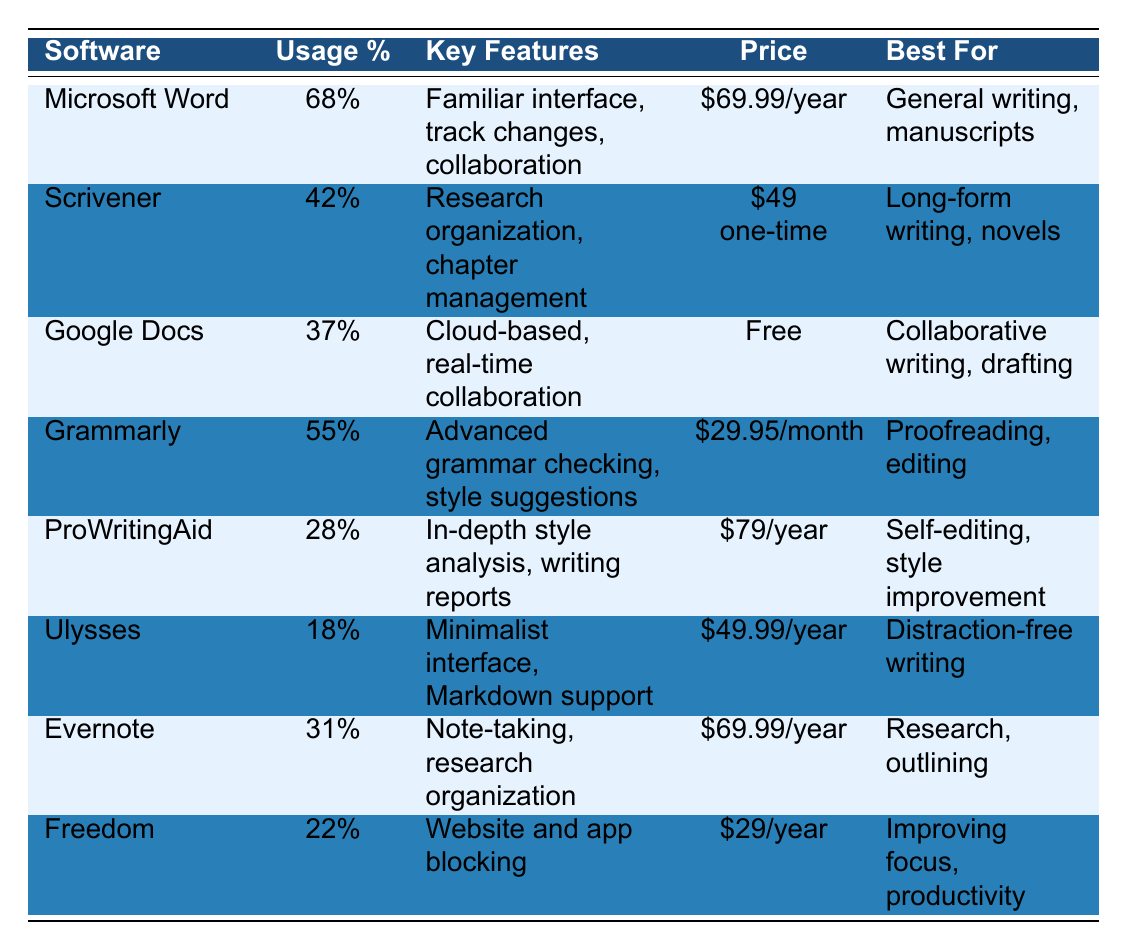What is the most popular writing software among published authors? The table shows the usage percentage of various writing software, with Microsoft Word having the highest at 68%.
Answer: Microsoft Word Which software has the lowest usage percentage? By comparing the usage percentages, Ulysses has the lowest at 18%.
Answer: Ulysses What is the price of Grammarly? The table lists Grammarly's price as $29.95 per month.
Answer: $29.95/month Is Google Docs a paid software? The table indicates that Google Docs is free, so this is a no.
Answer: No How many writing tools have a usage percentage of 30% or less? The following tools have usage percentages of 30% or less: ProWritingAid (28%), Freedom (22%), and Ulysses (18%). That's three tools.
Answer: 3 Calculate the average usage percentage of all listed writing tools. The total usage percentages sum up to 68 + 42 + 37 + 55 + 28 + 18 + 31 + 22 =  303. There are 8 tools, so the average is 303/8 = 37.875%.
Answer: 37.875% Which writing tool is best for long-form writing and how much does it cost? Scrivener is noted as best for long-form writing, and its price is $49 as a one-time fee.
Answer: Scrivener, $49 How does the usage percentage of Grammarly compare to that of ProWritingAid? Grammarly has a 55% usage whereas ProWritingAid has a 28% usage, showing that Grammarly is more widely used.
Answer: Grammarly is more widely used What are the key features of Microsoft Word? The table lists Microsoft's key features as a familiar interface, track changes, and collaboration.
Answer: Familiar interface, track changes, collaboration If an author wants to focus on productivity by blocking distractions, which tool should they choose and what is its cost? Freedom is the tool designed for website and app blocking to improve focus, with a cost of $29 per year.
Answer: Freedom, $29/year 